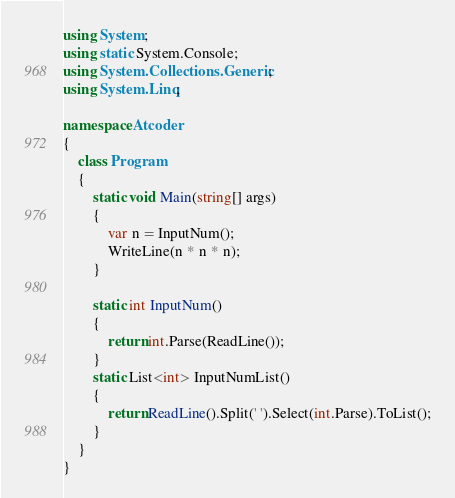<code> <loc_0><loc_0><loc_500><loc_500><_C#_>using System;
using static System.Console;
using System.Collections.Generic;
using System.Linq;

namespace Atcoder
{
    class Program
    {
        static void Main(string[] args)
        {
            var n = InputNum();
            WriteLine(n * n * n);
        }

        static int InputNum()
        {
            return int.Parse(ReadLine());
        }
        static List<int> InputNumList()
        {
            return ReadLine().Split(' ').Select(int.Parse).ToList();
        }
    }
}</code> 